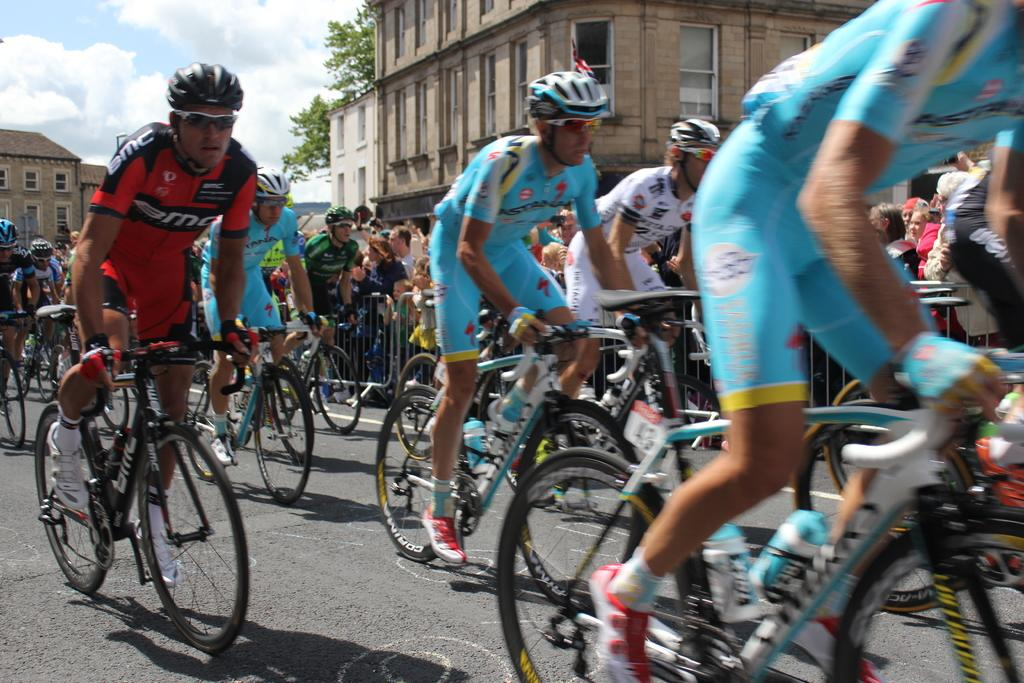What are the people in the image doing? The people in the image are riding bicycles. Where are the people riding their bicycles? The people are on the road. What can be seen in the background of the image? There are buildings, trees, and the sky visible in the background of the image. What is the condition of the sky in the image? The sky is visible in the background of the image, and clouds are visible in the sky. What type of stocking is the person wearing while riding the bicycle in the image? There is no information about stockings or any clothing items worn by the people in the image. --- Facts: 1. There is a person holding a book in the image. 2. The book has a blue cover. 3. The person is sitting on a chair. 4. There is a table next to the chair. 5. A lamp is on the table. Absurd Topics: elephant, ocean, volcano Conversation: What is the person in the image holding? The person in the image is holding a book. What color is the book's cover? The book has a blue cover. Where is the person sitting? The person is sitting on a chair. What is located next to the chair? There is a table next to the chair. What object is on the table? A lamp is on the table. Reasoning: Let's think step by step in order to produce the conversation. We start by identifying the main subject in the image, which is the person holding a book. Then, we describe the book's cover color, which is blue. Next, we mention the person's location, which is sitting on a chair. We then expand the conversation to include the table and lamp, which are also visible in the image. Absurd Question/Answer: Can you see an elephant swimming in the ocean in the image? No, there is no elephant or ocean present in the image. 